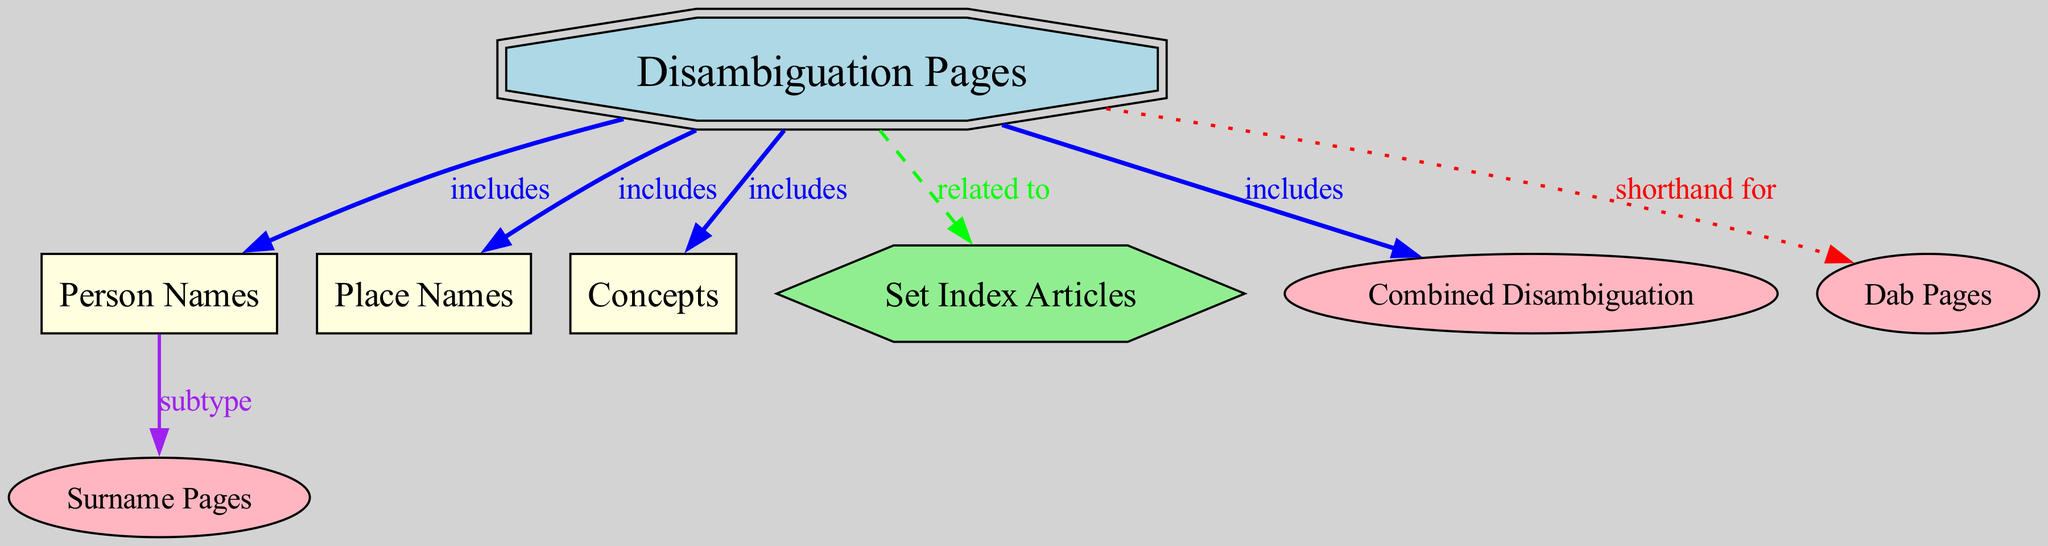What are the main types of disambiguation pages listed in the diagram? The diagram displays several main types of disambiguation pages: Person Names, Place Names, Concepts, Set Index Articles, Combined Disambiguation, and Dab Pages.
Answer: Person Names, Place Names, Concepts, Set Index Articles, Combined Disambiguation, Dab Pages How many types of disambiguation pages are included under "Disambiguation Pages"? Referring to the "Disambiguation Pages" node, there are six types directly connected to it: Person Names, Place Names, Concepts, Set Index Articles, Combined Disambiguation, and Dab Pages.
Answer: 6 Which type of disambiguation page is related to "Set Index Articles"? The diagram indicates that "Set Index Articles" is connected to "Disambiguation Pages" with the label "related to." Therefore, "Set Index Articles" itself is not a subtype under "Disambiguation Pages" but is a related concept.
Answer: Set Index Articles What is the relationship between "Person Names" and "Surname Pages"? The diagram shows the edge from "Person Names" to "Surname Pages" labeled as "subtype," indicating that "Surname Pages" is a specific type within the broader category of "Person Names."
Answer: subtype Which type of disambiguation page is often referred to as "Dab Pages"? The edge labeled "shorthand for" connects "Disambiguation Pages" to "Dab Pages," meaning that "Dab Pages" is another name or term used for disambiguation pages generally.
Answer: Dab Pages How many edges are there in this diagram? The diagram consists of a total of seven edges connecting the nodes, each representing various relationships among the types of disambiguation pages.
Answer: 7 Which two types of disambiguation pages classified under "Disambiguation Pages" are specifically included as a detail rather than a generalization? The relationship indicates that "Person Names" is a general category that includes "Surname Pages" as a subtype, thus indicating the specific nature of "Surname Pages" under "Person Names."
Answer: Surname Pages What connections does the "combined" disambiguation type have? The "Combined Disambiguation" is connected to "Disambiguation Pages" as it is included among the types, but no specific subtypes beneath it are visible, which signifies its connection as another variant option of disambiguation.
Answer: Disambiguation Pages 